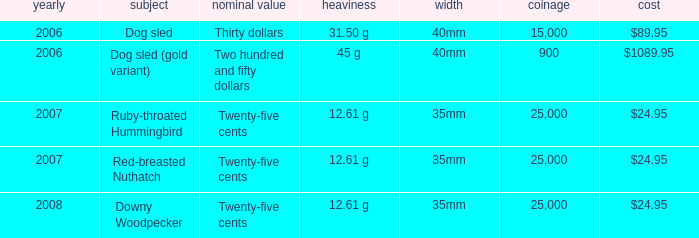What is the Year of the Coin with an Issue Price of $1089.95 and Mintage less than 900? None. 